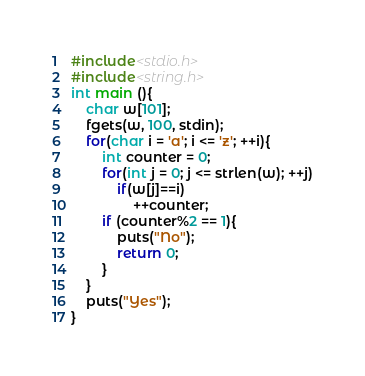Convert code to text. <code><loc_0><loc_0><loc_500><loc_500><_C_>#include<stdio.h>
#include<string.h>
int main (){
	char w[101];
	fgets(w, 100, stdin);
	for(char i = 'a'; i <= 'z'; ++i){
		int counter = 0;
		for(int j = 0; j <= strlen(w); ++j)
			if(w[j]==i)
				++counter;
		if (counter%2 == 1){
			puts("No");
			return 0;
		}
	}
	puts("Yes");
}
</code> 